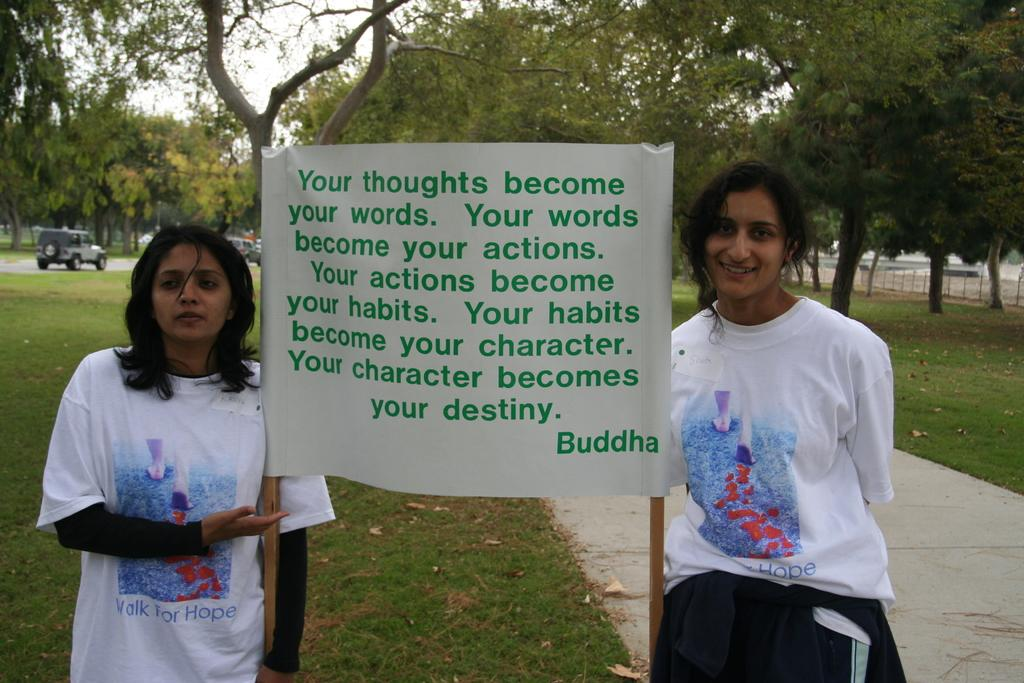<image>
Relay a brief, clear account of the picture shown. a couple of girls that have a sign with a quote from Buddha 